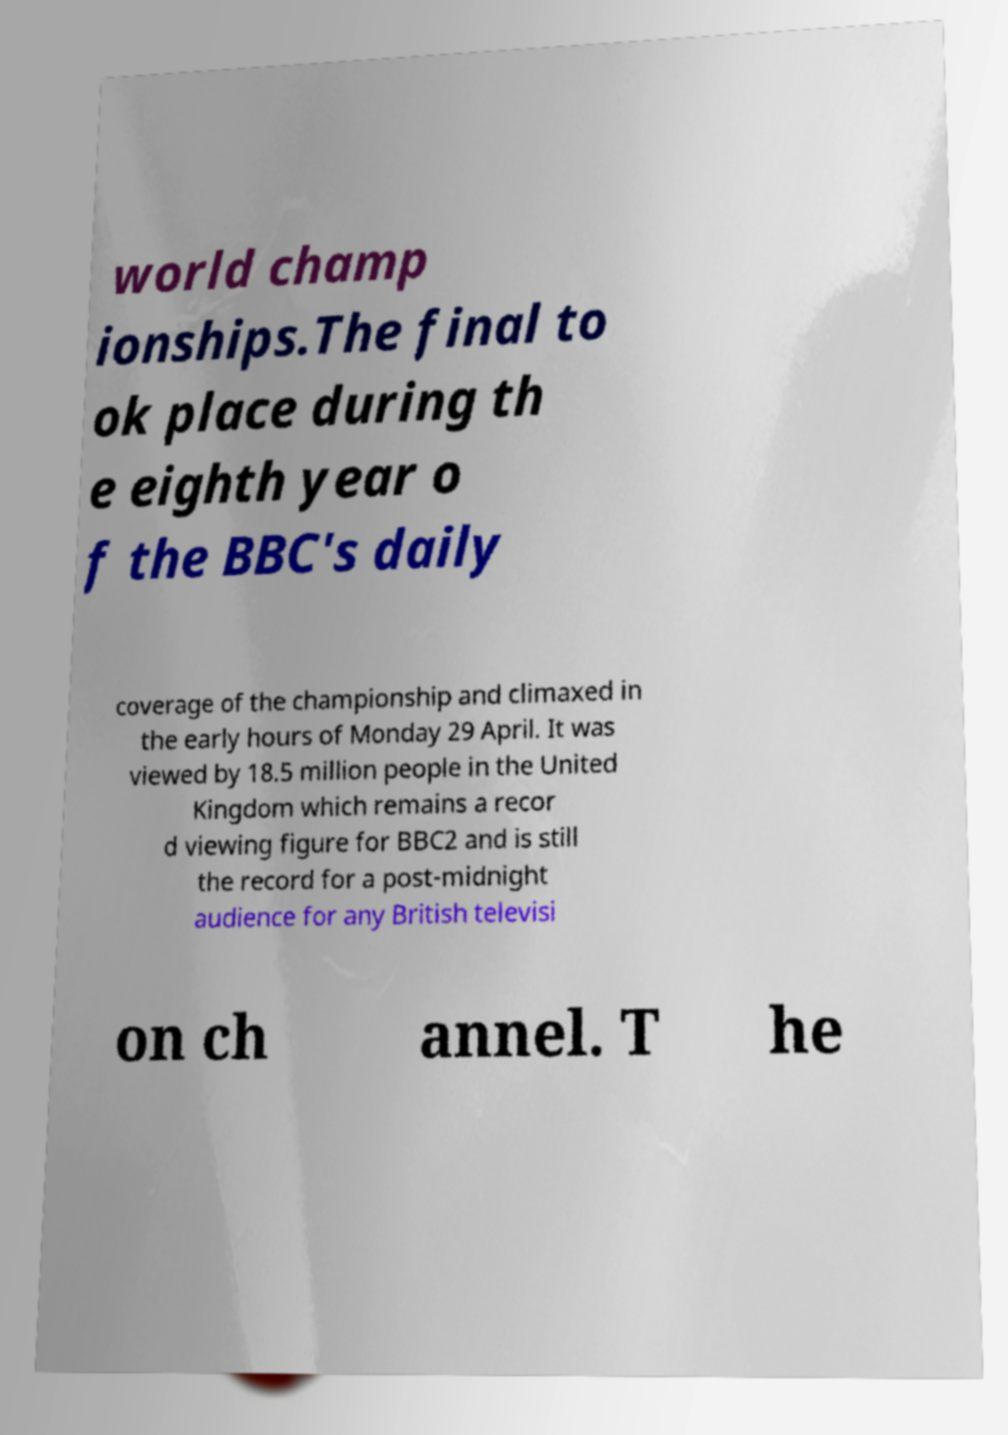I need the written content from this picture converted into text. Can you do that? world champ ionships.The final to ok place during th e eighth year o f the BBC's daily coverage of the championship and climaxed in the early hours of Monday 29 April. It was viewed by 18.5 million people in the United Kingdom which remains a recor d viewing figure for BBC2 and is still the record for a post-midnight audience for any British televisi on ch annel. T he 